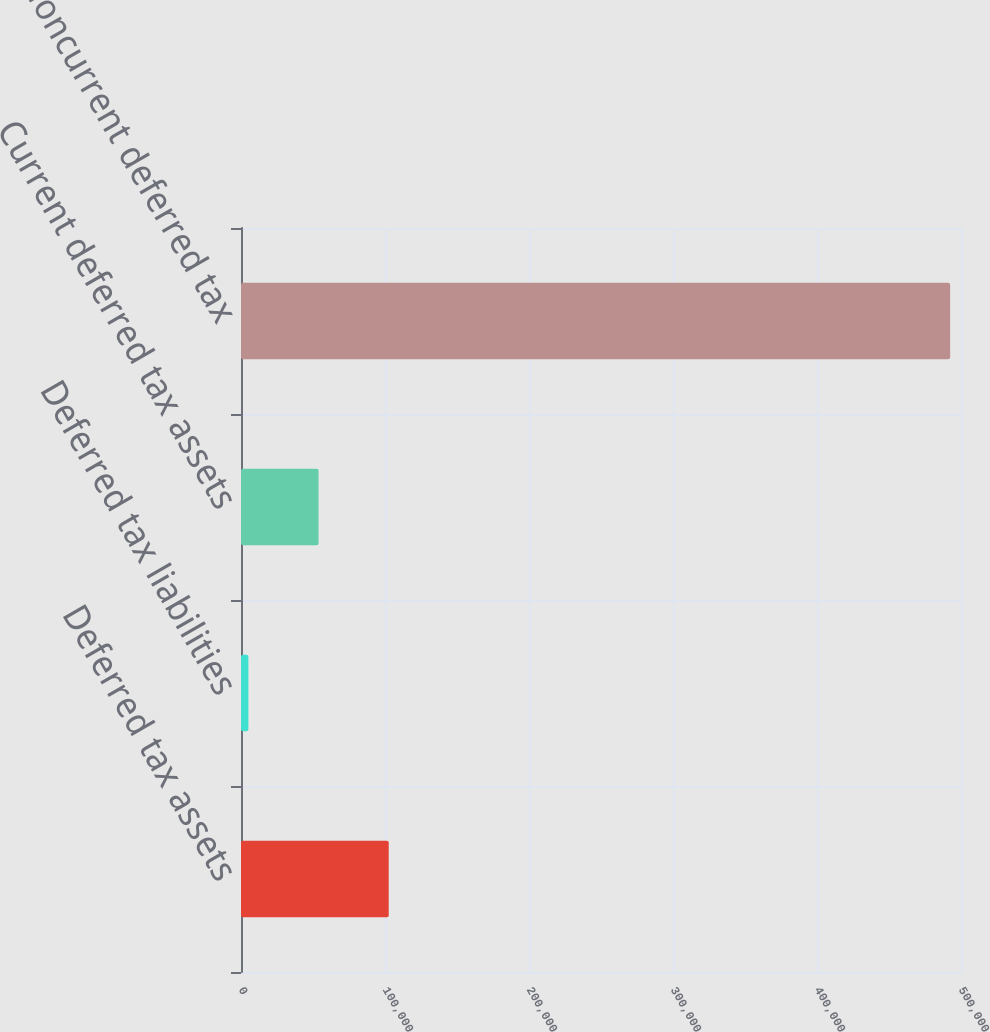Convert chart. <chart><loc_0><loc_0><loc_500><loc_500><bar_chart><fcel>Deferred tax assets<fcel>Deferred tax liabilities<fcel>Current deferred tax assets<fcel>Noncurrent deferred tax<nl><fcel>102586<fcel>5117<fcel>53851.7<fcel>492464<nl></chart> 